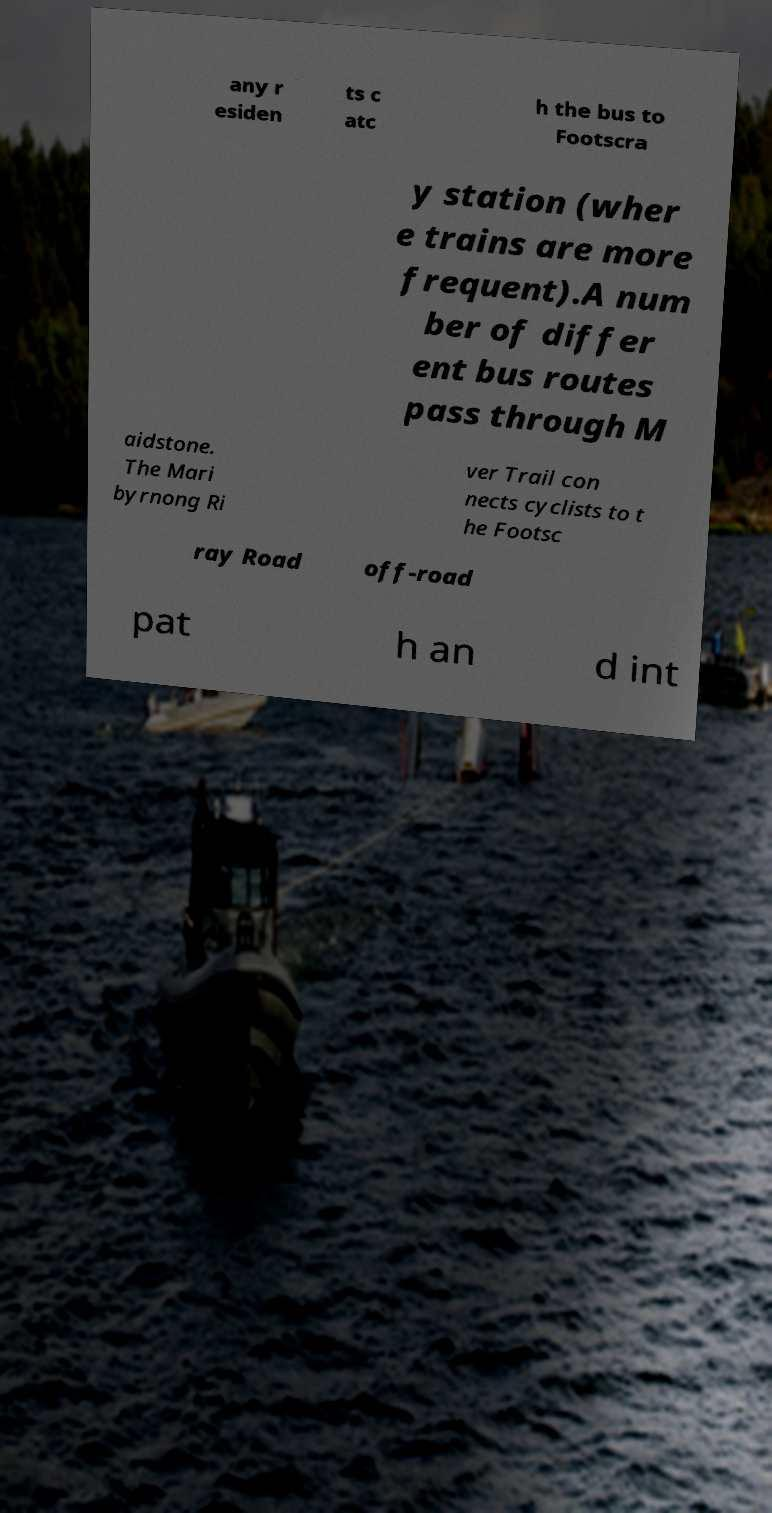For documentation purposes, I need the text within this image transcribed. Could you provide that? any r esiden ts c atc h the bus to Footscra y station (wher e trains are more frequent).A num ber of differ ent bus routes pass through M aidstone. The Mari byrnong Ri ver Trail con nects cyclists to t he Footsc ray Road off-road pat h an d int 